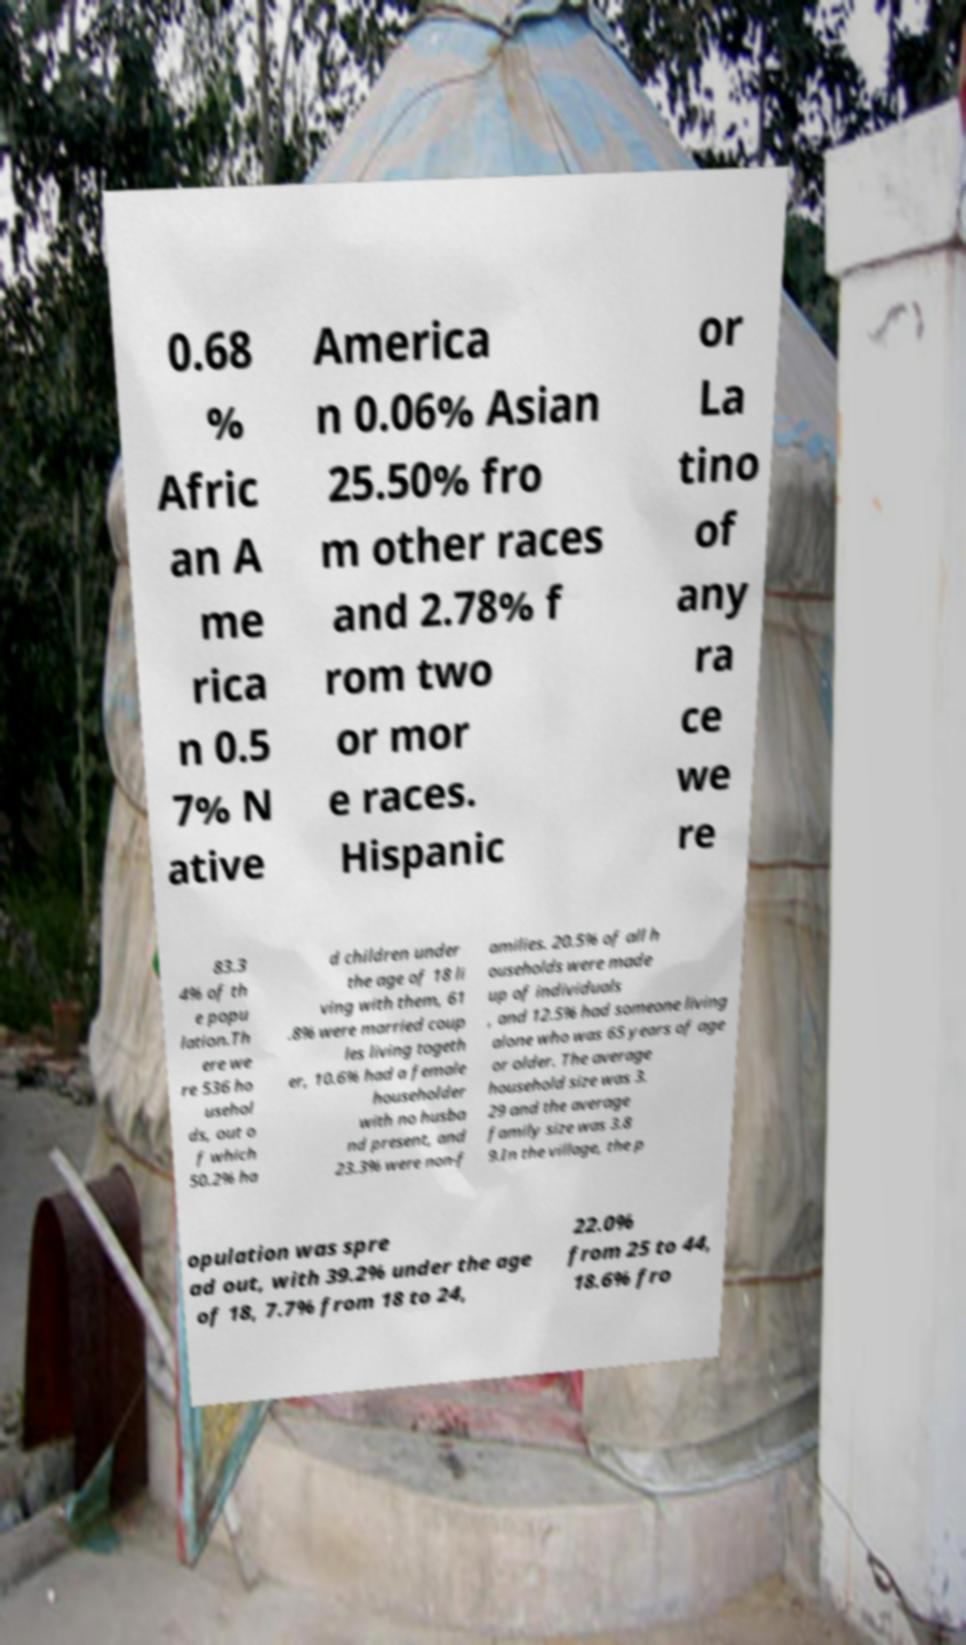For documentation purposes, I need the text within this image transcribed. Could you provide that? 0.68 % Afric an A me rica n 0.5 7% N ative America n 0.06% Asian 25.50% fro m other races and 2.78% f rom two or mor e races. Hispanic or La tino of any ra ce we re 83.3 4% of th e popu lation.Th ere we re 536 ho usehol ds, out o f which 50.2% ha d children under the age of 18 li ving with them, 61 .8% were married coup les living togeth er, 10.6% had a female householder with no husba nd present, and 23.3% were non-f amilies. 20.5% of all h ouseholds were made up of individuals , and 12.5% had someone living alone who was 65 years of age or older. The average household size was 3. 29 and the average family size was 3.8 9.In the village, the p opulation was spre ad out, with 39.2% under the age of 18, 7.7% from 18 to 24, 22.0% from 25 to 44, 18.6% fro 